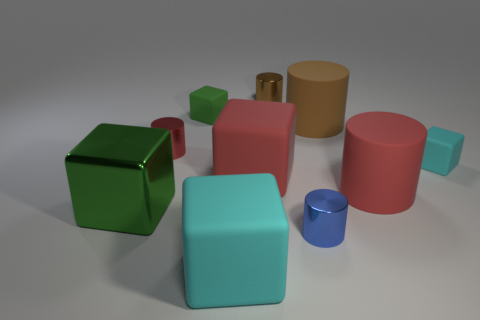Subtract all purple cylinders. How many green cubes are left? 2 Subtract all large cyan matte cubes. How many cubes are left? 4 Subtract 2 cylinders. How many cylinders are left? 3 Subtract all red cubes. How many cubes are left? 4 Subtract all purple cylinders. Subtract all cyan blocks. How many cylinders are left? 5 Subtract 1 cyan cubes. How many objects are left? 9 Subtract all small red metal cylinders. Subtract all small brown metallic cylinders. How many objects are left? 8 Add 2 tiny brown metal objects. How many tiny brown metal objects are left? 3 Add 6 blue things. How many blue things exist? 7 